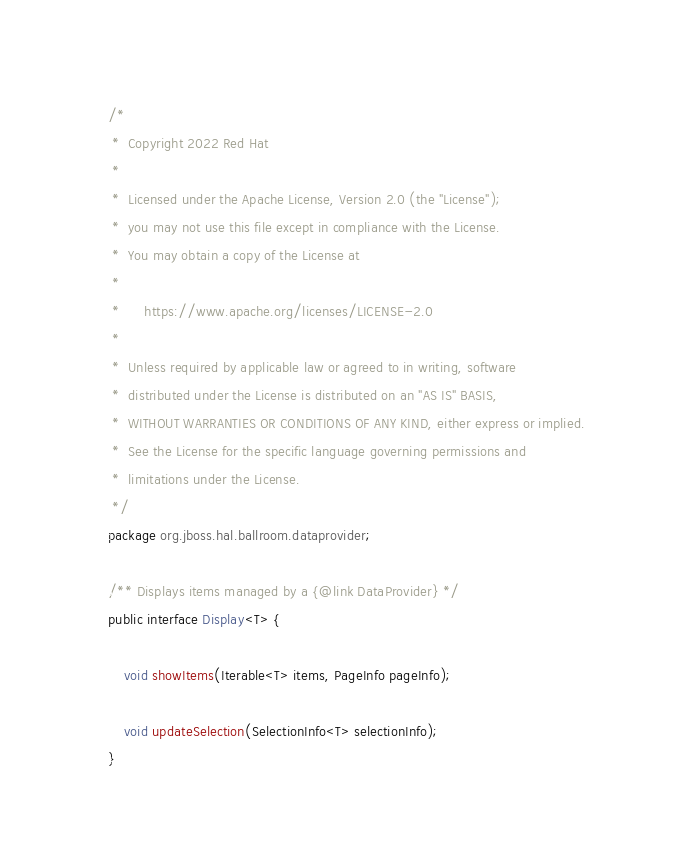<code> <loc_0><loc_0><loc_500><loc_500><_Java_>/*
 *  Copyright 2022 Red Hat
 *
 *  Licensed under the Apache License, Version 2.0 (the "License");
 *  you may not use this file except in compliance with the License.
 *  You may obtain a copy of the License at
 *
 *      https://www.apache.org/licenses/LICENSE-2.0
 *
 *  Unless required by applicable law or agreed to in writing, software
 *  distributed under the License is distributed on an "AS IS" BASIS,
 *  WITHOUT WARRANTIES OR CONDITIONS OF ANY KIND, either express or implied.
 *  See the License for the specific language governing permissions and
 *  limitations under the License.
 */
package org.jboss.hal.ballroom.dataprovider;

/** Displays items managed by a {@link DataProvider} */
public interface Display<T> {

    void showItems(Iterable<T> items, PageInfo pageInfo);

    void updateSelection(SelectionInfo<T> selectionInfo);
}
</code> 